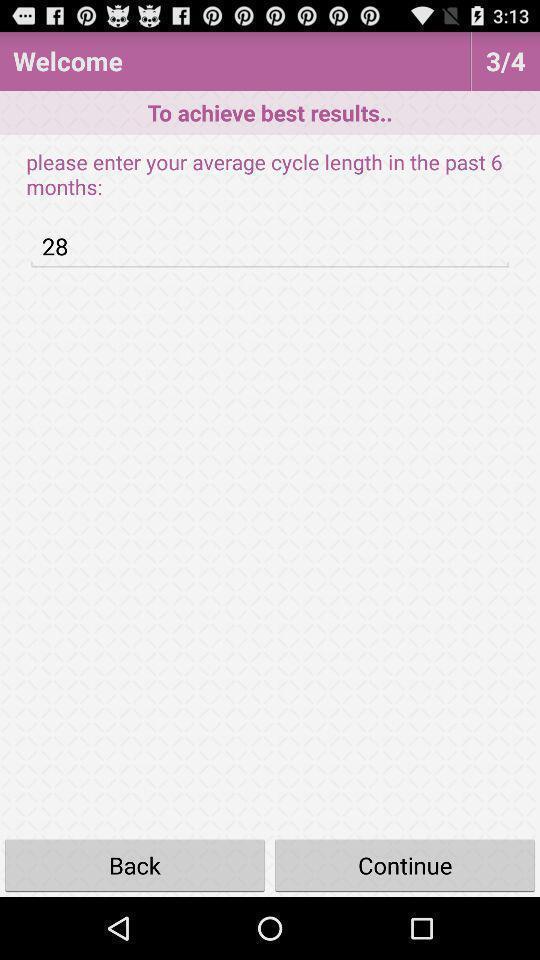Explain the elements present in this screenshot. Welcome page of the results. 